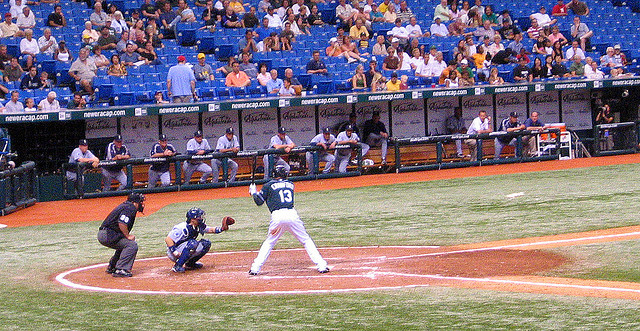Identify the text contained in this image. 13 